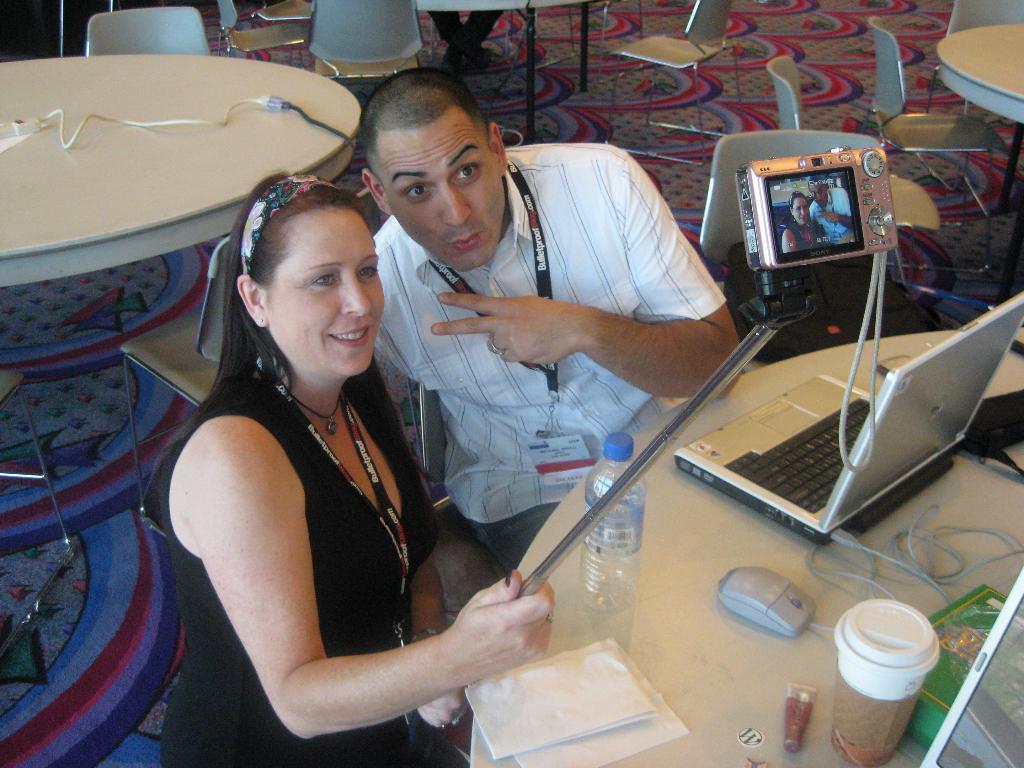Please provide a concise description of this image. there is a man and woman wearing a black tag smiling to the camera behind them there is a table with the laptop and the coffee cup on it. 